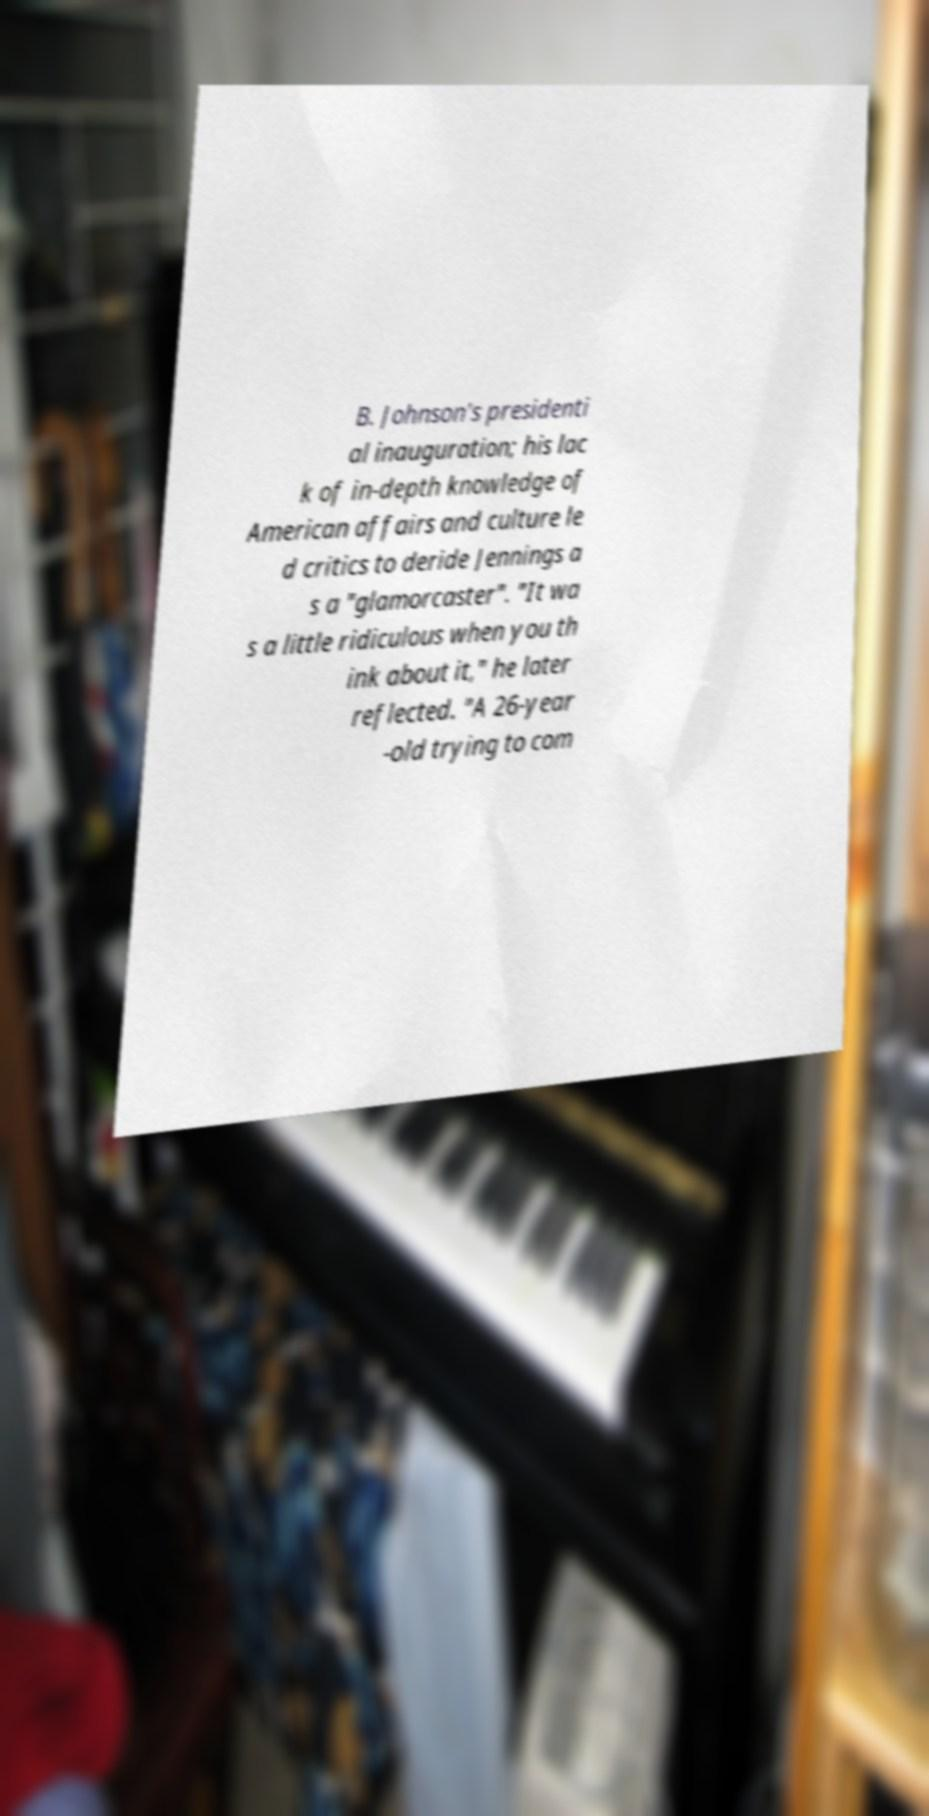Can you read and provide the text displayed in the image?This photo seems to have some interesting text. Can you extract and type it out for me? B. Johnson's presidenti al inauguration; his lac k of in-depth knowledge of American affairs and culture le d critics to deride Jennings a s a "glamorcaster". "It wa s a little ridiculous when you th ink about it," he later reflected. "A 26-year -old trying to com 